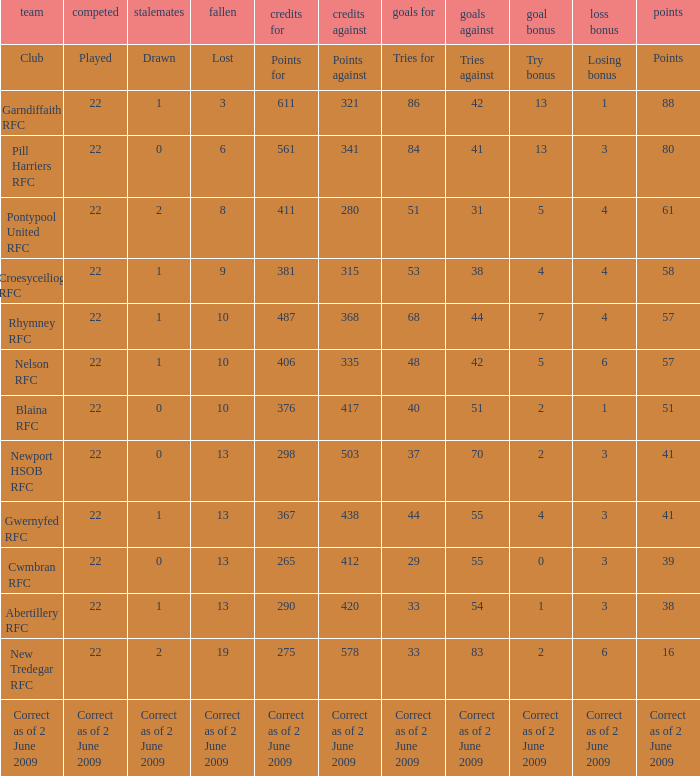How many tries did the club Croesyceiliog rfc have? 53.0. 